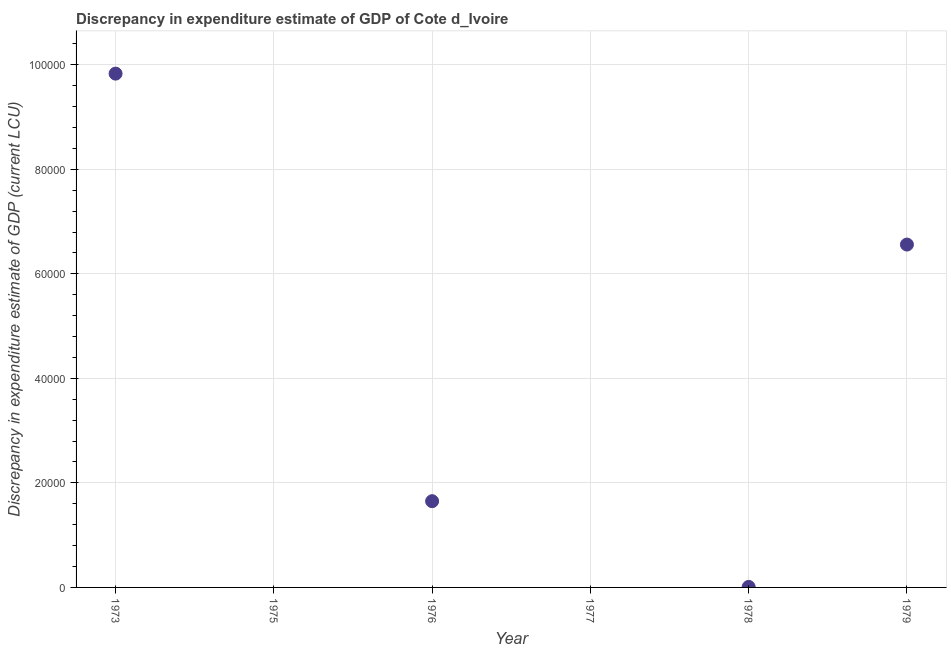What is the discrepancy in expenditure estimate of gdp in 1975?
Provide a short and direct response. 0. Across all years, what is the maximum discrepancy in expenditure estimate of gdp?
Provide a succinct answer. 9.83e+04. What is the sum of the discrepancy in expenditure estimate of gdp?
Your answer should be compact. 1.80e+05. What is the difference between the discrepancy in expenditure estimate of gdp in 1973 and 1978?
Keep it short and to the point. 9.82e+04. What is the average discrepancy in expenditure estimate of gdp per year?
Your answer should be compact. 3.01e+04. What is the median discrepancy in expenditure estimate of gdp?
Keep it short and to the point. 8300. What is the ratio of the discrepancy in expenditure estimate of gdp in 1973 to that in 1976?
Provide a succinct answer. 5.96. Is the discrepancy in expenditure estimate of gdp in 1978 less than that in 1979?
Your answer should be compact. Yes. Is the difference between the discrepancy in expenditure estimate of gdp in 1973 and 1978 greater than the difference between any two years?
Give a very brief answer. No. What is the difference between the highest and the second highest discrepancy in expenditure estimate of gdp?
Make the answer very short. 3.27e+04. What is the difference between the highest and the lowest discrepancy in expenditure estimate of gdp?
Your response must be concise. 9.83e+04. In how many years, is the discrepancy in expenditure estimate of gdp greater than the average discrepancy in expenditure estimate of gdp taken over all years?
Your answer should be compact. 2. Does the discrepancy in expenditure estimate of gdp monotonically increase over the years?
Your response must be concise. No. How many dotlines are there?
Your answer should be very brief. 1. What is the difference between two consecutive major ticks on the Y-axis?
Keep it short and to the point. 2.00e+04. Does the graph contain any zero values?
Provide a short and direct response. Yes. What is the title of the graph?
Your answer should be very brief. Discrepancy in expenditure estimate of GDP of Cote d_Ivoire. What is the label or title of the Y-axis?
Provide a succinct answer. Discrepancy in expenditure estimate of GDP (current LCU). What is the Discrepancy in expenditure estimate of GDP (current LCU) in 1973?
Give a very brief answer. 9.83e+04. What is the Discrepancy in expenditure estimate of GDP (current LCU) in 1975?
Provide a succinct answer. 0. What is the Discrepancy in expenditure estimate of GDP (current LCU) in 1976?
Your response must be concise. 1.65e+04. What is the Discrepancy in expenditure estimate of GDP (current LCU) in 1977?
Offer a very short reply. 0. What is the Discrepancy in expenditure estimate of GDP (current LCU) in 1978?
Make the answer very short. 100. What is the Discrepancy in expenditure estimate of GDP (current LCU) in 1979?
Provide a short and direct response. 6.56e+04. What is the difference between the Discrepancy in expenditure estimate of GDP (current LCU) in 1973 and 1976?
Ensure brevity in your answer.  8.18e+04. What is the difference between the Discrepancy in expenditure estimate of GDP (current LCU) in 1973 and 1978?
Make the answer very short. 9.82e+04. What is the difference between the Discrepancy in expenditure estimate of GDP (current LCU) in 1973 and 1979?
Your answer should be compact. 3.27e+04. What is the difference between the Discrepancy in expenditure estimate of GDP (current LCU) in 1976 and 1978?
Your answer should be very brief. 1.64e+04. What is the difference between the Discrepancy in expenditure estimate of GDP (current LCU) in 1976 and 1979?
Offer a terse response. -4.91e+04. What is the difference between the Discrepancy in expenditure estimate of GDP (current LCU) in 1978 and 1979?
Give a very brief answer. -6.55e+04. What is the ratio of the Discrepancy in expenditure estimate of GDP (current LCU) in 1973 to that in 1976?
Provide a succinct answer. 5.96. What is the ratio of the Discrepancy in expenditure estimate of GDP (current LCU) in 1973 to that in 1978?
Offer a terse response. 983. What is the ratio of the Discrepancy in expenditure estimate of GDP (current LCU) in 1973 to that in 1979?
Provide a short and direct response. 1.5. What is the ratio of the Discrepancy in expenditure estimate of GDP (current LCU) in 1976 to that in 1978?
Your response must be concise. 165. What is the ratio of the Discrepancy in expenditure estimate of GDP (current LCU) in 1976 to that in 1979?
Offer a terse response. 0.25. What is the ratio of the Discrepancy in expenditure estimate of GDP (current LCU) in 1978 to that in 1979?
Offer a terse response. 0. 